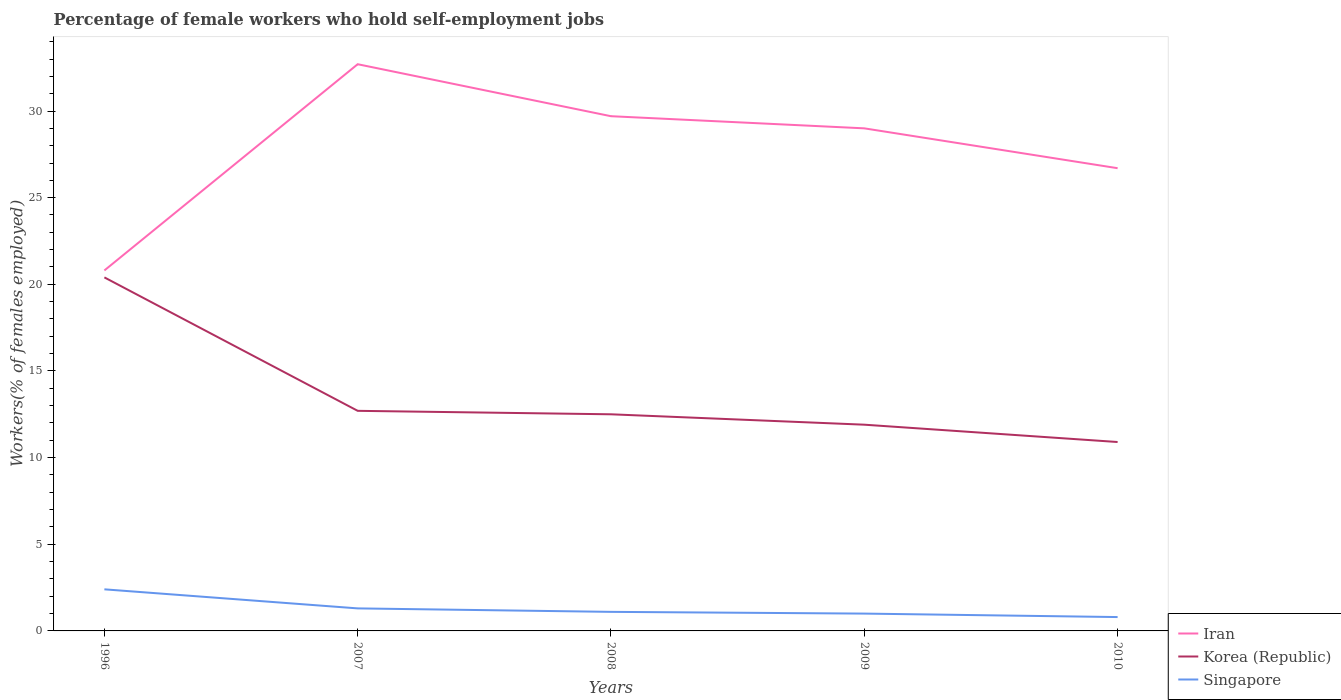How many different coloured lines are there?
Give a very brief answer. 3. Does the line corresponding to Singapore intersect with the line corresponding to Iran?
Keep it short and to the point. No. Is the number of lines equal to the number of legend labels?
Offer a terse response. Yes. Across all years, what is the maximum percentage of self-employed female workers in Korea (Republic)?
Your answer should be compact. 10.9. In which year was the percentage of self-employed female workers in Iran maximum?
Your answer should be compact. 1996. What is the total percentage of self-employed female workers in Korea (Republic) in the graph?
Your answer should be compact. 0.2. What is the difference between the highest and the second highest percentage of self-employed female workers in Singapore?
Make the answer very short. 1.6. What is the difference between the highest and the lowest percentage of self-employed female workers in Iran?
Your answer should be compact. 3. How many lines are there?
Make the answer very short. 3. What is the difference between two consecutive major ticks on the Y-axis?
Keep it short and to the point. 5. Does the graph contain any zero values?
Keep it short and to the point. No. Does the graph contain grids?
Provide a succinct answer. No. Where does the legend appear in the graph?
Your response must be concise. Bottom right. How many legend labels are there?
Keep it short and to the point. 3. What is the title of the graph?
Ensure brevity in your answer.  Percentage of female workers who hold self-employment jobs. Does "Lao PDR" appear as one of the legend labels in the graph?
Provide a succinct answer. No. What is the label or title of the X-axis?
Provide a succinct answer. Years. What is the label or title of the Y-axis?
Provide a succinct answer. Workers(% of females employed). What is the Workers(% of females employed) in Iran in 1996?
Your response must be concise. 20.8. What is the Workers(% of females employed) of Korea (Republic) in 1996?
Provide a short and direct response. 20.4. What is the Workers(% of females employed) in Singapore in 1996?
Provide a succinct answer. 2.4. What is the Workers(% of females employed) of Iran in 2007?
Provide a short and direct response. 32.7. What is the Workers(% of females employed) of Korea (Republic) in 2007?
Provide a short and direct response. 12.7. What is the Workers(% of females employed) in Singapore in 2007?
Offer a very short reply. 1.3. What is the Workers(% of females employed) of Iran in 2008?
Give a very brief answer. 29.7. What is the Workers(% of females employed) of Singapore in 2008?
Keep it short and to the point. 1.1. What is the Workers(% of females employed) in Iran in 2009?
Keep it short and to the point. 29. What is the Workers(% of females employed) in Korea (Republic) in 2009?
Provide a succinct answer. 11.9. What is the Workers(% of females employed) of Singapore in 2009?
Provide a succinct answer. 1. What is the Workers(% of females employed) of Iran in 2010?
Keep it short and to the point. 26.7. What is the Workers(% of females employed) in Korea (Republic) in 2010?
Give a very brief answer. 10.9. What is the Workers(% of females employed) in Singapore in 2010?
Offer a terse response. 0.8. Across all years, what is the maximum Workers(% of females employed) in Iran?
Your answer should be very brief. 32.7. Across all years, what is the maximum Workers(% of females employed) in Korea (Republic)?
Give a very brief answer. 20.4. Across all years, what is the maximum Workers(% of females employed) in Singapore?
Give a very brief answer. 2.4. Across all years, what is the minimum Workers(% of females employed) in Iran?
Keep it short and to the point. 20.8. Across all years, what is the minimum Workers(% of females employed) in Korea (Republic)?
Offer a terse response. 10.9. Across all years, what is the minimum Workers(% of females employed) in Singapore?
Offer a very short reply. 0.8. What is the total Workers(% of females employed) in Iran in the graph?
Keep it short and to the point. 138.9. What is the total Workers(% of females employed) of Korea (Republic) in the graph?
Give a very brief answer. 68.4. What is the difference between the Workers(% of females employed) of Iran in 1996 and that in 2008?
Keep it short and to the point. -8.9. What is the difference between the Workers(% of females employed) in Korea (Republic) in 1996 and that in 2008?
Make the answer very short. 7.9. What is the difference between the Workers(% of females employed) in Singapore in 1996 and that in 2008?
Keep it short and to the point. 1.3. What is the difference between the Workers(% of females employed) in Iran in 1996 and that in 2009?
Ensure brevity in your answer.  -8.2. What is the difference between the Workers(% of females employed) in Korea (Republic) in 1996 and that in 2009?
Keep it short and to the point. 8.5. What is the difference between the Workers(% of females employed) in Singapore in 1996 and that in 2009?
Offer a very short reply. 1.4. What is the difference between the Workers(% of females employed) of Iran in 1996 and that in 2010?
Provide a succinct answer. -5.9. What is the difference between the Workers(% of females employed) in Korea (Republic) in 1996 and that in 2010?
Keep it short and to the point. 9.5. What is the difference between the Workers(% of females employed) of Iran in 2007 and that in 2009?
Provide a short and direct response. 3.7. What is the difference between the Workers(% of females employed) of Korea (Republic) in 2007 and that in 2009?
Offer a terse response. 0.8. What is the difference between the Workers(% of females employed) in Singapore in 2007 and that in 2009?
Provide a succinct answer. 0.3. What is the difference between the Workers(% of females employed) of Singapore in 2007 and that in 2010?
Keep it short and to the point. 0.5. What is the difference between the Workers(% of females employed) in Iran in 2008 and that in 2009?
Offer a terse response. 0.7. What is the difference between the Workers(% of females employed) in Singapore in 2008 and that in 2009?
Give a very brief answer. 0.1. What is the difference between the Workers(% of females employed) in Singapore in 2008 and that in 2010?
Provide a succinct answer. 0.3. What is the difference between the Workers(% of females employed) of Iran in 2009 and that in 2010?
Keep it short and to the point. 2.3. What is the difference between the Workers(% of females employed) of Korea (Republic) in 2009 and that in 2010?
Give a very brief answer. 1. What is the difference between the Workers(% of females employed) in Singapore in 2009 and that in 2010?
Ensure brevity in your answer.  0.2. What is the difference between the Workers(% of females employed) in Iran in 1996 and the Workers(% of females employed) in Korea (Republic) in 2007?
Your answer should be very brief. 8.1. What is the difference between the Workers(% of females employed) of Iran in 1996 and the Workers(% of females employed) of Korea (Republic) in 2008?
Provide a short and direct response. 8.3. What is the difference between the Workers(% of females employed) in Iran in 1996 and the Workers(% of females employed) in Singapore in 2008?
Keep it short and to the point. 19.7. What is the difference between the Workers(% of females employed) of Korea (Republic) in 1996 and the Workers(% of females employed) of Singapore in 2008?
Give a very brief answer. 19.3. What is the difference between the Workers(% of females employed) of Iran in 1996 and the Workers(% of females employed) of Korea (Republic) in 2009?
Offer a very short reply. 8.9. What is the difference between the Workers(% of females employed) in Iran in 1996 and the Workers(% of females employed) in Singapore in 2009?
Offer a very short reply. 19.8. What is the difference between the Workers(% of females employed) of Korea (Republic) in 1996 and the Workers(% of females employed) of Singapore in 2009?
Provide a succinct answer. 19.4. What is the difference between the Workers(% of females employed) in Iran in 1996 and the Workers(% of females employed) in Korea (Republic) in 2010?
Your answer should be compact. 9.9. What is the difference between the Workers(% of females employed) of Korea (Republic) in 1996 and the Workers(% of females employed) of Singapore in 2010?
Provide a succinct answer. 19.6. What is the difference between the Workers(% of females employed) of Iran in 2007 and the Workers(% of females employed) of Korea (Republic) in 2008?
Give a very brief answer. 20.2. What is the difference between the Workers(% of females employed) of Iran in 2007 and the Workers(% of females employed) of Singapore in 2008?
Provide a short and direct response. 31.6. What is the difference between the Workers(% of females employed) in Korea (Republic) in 2007 and the Workers(% of females employed) in Singapore in 2008?
Offer a terse response. 11.6. What is the difference between the Workers(% of females employed) in Iran in 2007 and the Workers(% of females employed) in Korea (Republic) in 2009?
Keep it short and to the point. 20.8. What is the difference between the Workers(% of females employed) in Iran in 2007 and the Workers(% of females employed) in Singapore in 2009?
Offer a terse response. 31.7. What is the difference between the Workers(% of females employed) in Iran in 2007 and the Workers(% of females employed) in Korea (Republic) in 2010?
Ensure brevity in your answer.  21.8. What is the difference between the Workers(% of females employed) of Iran in 2007 and the Workers(% of females employed) of Singapore in 2010?
Offer a very short reply. 31.9. What is the difference between the Workers(% of females employed) in Korea (Republic) in 2007 and the Workers(% of females employed) in Singapore in 2010?
Provide a short and direct response. 11.9. What is the difference between the Workers(% of females employed) in Iran in 2008 and the Workers(% of females employed) in Korea (Republic) in 2009?
Your answer should be very brief. 17.8. What is the difference between the Workers(% of females employed) of Iran in 2008 and the Workers(% of females employed) of Singapore in 2009?
Make the answer very short. 28.7. What is the difference between the Workers(% of females employed) of Korea (Republic) in 2008 and the Workers(% of females employed) of Singapore in 2009?
Offer a very short reply. 11.5. What is the difference between the Workers(% of females employed) of Iran in 2008 and the Workers(% of females employed) of Korea (Republic) in 2010?
Your answer should be compact. 18.8. What is the difference between the Workers(% of females employed) of Iran in 2008 and the Workers(% of females employed) of Singapore in 2010?
Offer a very short reply. 28.9. What is the difference between the Workers(% of females employed) in Korea (Republic) in 2008 and the Workers(% of females employed) in Singapore in 2010?
Offer a terse response. 11.7. What is the difference between the Workers(% of females employed) in Iran in 2009 and the Workers(% of females employed) in Korea (Republic) in 2010?
Your answer should be compact. 18.1. What is the difference between the Workers(% of females employed) in Iran in 2009 and the Workers(% of females employed) in Singapore in 2010?
Make the answer very short. 28.2. What is the difference between the Workers(% of females employed) of Korea (Republic) in 2009 and the Workers(% of females employed) of Singapore in 2010?
Provide a succinct answer. 11.1. What is the average Workers(% of females employed) in Iran per year?
Your answer should be very brief. 27.78. What is the average Workers(% of females employed) of Korea (Republic) per year?
Make the answer very short. 13.68. What is the average Workers(% of females employed) of Singapore per year?
Give a very brief answer. 1.32. In the year 1996, what is the difference between the Workers(% of females employed) in Iran and Workers(% of females employed) in Korea (Republic)?
Provide a short and direct response. 0.4. In the year 1996, what is the difference between the Workers(% of females employed) of Iran and Workers(% of females employed) of Singapore?
Your answer should be compact. 18.4. In the year 2007, what is the difference between the Workers(% of females employed) of Iran and Workers(% of females employed) of Korea (Republic)?
Offer a terse response. 20. In the year 2007, what is the difference between the Workers(% of females employed) in Iran and Workers(% of females employed) in Singapore?
Provide a succinct answer. 31.4. In the year 2007, what is the difference between the Workers(% of females employed) of Korea (Republic) and Workers(% of females employed) of Singapore?
Offer a terse response. 11.4. In the year 2008, what is the difference between the Workers(% of females employed) in Iran and Workers(% of females employed) in Singapore?
Provide a succinct answer. 28.6. In the year 2009, what is the difference between the Workers(% of females employed) in Iran and Workers(% of females employed) in Korea (Republic)?
Make the answer very short. 17.1. In the year 2009, what is the difference between the Workers(% of females employed) of Korea (Republic) and Workers(% of females employed) of Singapore?
Make the answer very short. 10.9. In the year 2010, what is the difference between the Workers(% of females employed) of Iran and Workers(% of females employed) of Singapore?
Your answer should be very brief. 25.9. In the year 2010, what is the difference between the Workers(% of females employed) in Korea (Republic) and Workers(% of females employed) in Singapore?
Provide a succinct answer. 10.1. What is the ratio of the Workers(% of females employed) in Iran in 1996 to that in 2007?
Offer a terse response. 0.64. What is the ratio of the Workers(% of females employed) of Korea (Republic) in 1996 to that in 2007?
Make the answer very short. 1.61. What is the ratio of the Workers(% of females employed) of Singapore in 1996 to that in 2007?
Your response must be concise. 1.85. What is the ratio of the Workers(% of females employed) of Iran in 1996 to that in 2008?
Provide a short and direct response. 0.7. What is the ratio of the Workers(% of females employed) in Korea (Republic) in 1996 to that in 2008?
Provide a succinct answer. 1.63. What is the ratio of the Workers(% of females employed) of Singapore in 1996 to that in 2008?
Make the answer very short. 2.18. What is the ratio of the Workers(% of females employed) in Iran in 1996 to that in 2009?
Keep it short and to the point. 0.72. What is the ratio of the Workers(% of females employed) in Korea (Republic) in 1996 to that in 2009?
Your response must be concise. 1.71. What is the ratio of the Workers(% of females employed) of Iran in 1996 to that in 2010?
Provide a succinct answer. 0.78. What is the ratio of the Workers(% of females employed) of Korea (Republic) in 1996 to that in 2010?
Offer a terse response. 1.87. What is the ratio of the Workers(% of females employed) of Singapore in 1996 to that in 2010?
Keep it short and to the point. 3. What is the ratio of the Workers(% of females employed) in Iran in 2007 to that in 2008?
Offer a terse response. 1.1. What is the ratio of the Workers(% of females employed) in Singapore in 2007 to that in 2008?
Keep it short and to the point. 1.18. What is the ratio of the Workers(% of females employed) of Iran in 2007 to that in 2009?
Offer a very short reply. 1.13. What is the ratio of the Workers(% of females employed) in Korea (Republic) in 2007 to that in 2009?
Offer a very short reply. 1.07. What is the ratio of the Workers(% of females employed) of Singapore in 2007 to that in 2009?
Provide a short and direct response. 1.3. What is the ratio of the Workers(% of females employed) in Iran in 2007 to that in 2010?
Offer a very short reply. 1.22. What is the ratio of the Workers(% of females employed) of Korea (Republic) in 2007 to that in 2010?
Give a very brief answer. 1.17. What is the ratio of the Workers(% of females employed) in Singapore in 2007 to that in 2010?
Your answer should be very brief. 1.62. What is the ratio of the Workers(% of females employed) in Iran in 2008 to that in 2009?
Keep it short and to the point. 1.02. What is the ratio of the Workers(% of females employed) of Korea (Republic) in 2008 to that in 2009?
Your answer should be very brief. 1.05. What is the ratio of the Workers(% of females employed) in Iran in 2008 to that in 2010?
Your answer should be compact. 1.11. What is the ratio of the Workers(% of females employed) of Korea (Republic) in 2008 to that in 2010?
Offer a terse response. 1.15. What is the ratio of the Workers(% of females employed) of Singapore in 2008 to that in 2010?
Offer a terse response. 1.38. What is the ratio of the Workers(% of females employed) in Iran in 2009 to that in 2010?
Offer a terse response. 1.09. What is the ratio of the Workers(% of females employed) in Korea (Republic) in 2009 to that in 2010?
Keep it short and to the point. 1.09. What is the difference between the highest and the lowest Workers(% of females employed) of Iran?
Your answer should be compact. 11.9. What is the difference between the highest and the lowest Workers(% of females employed) of Korea (Republic)?
Ensure brevity in your answer.  9.5. 